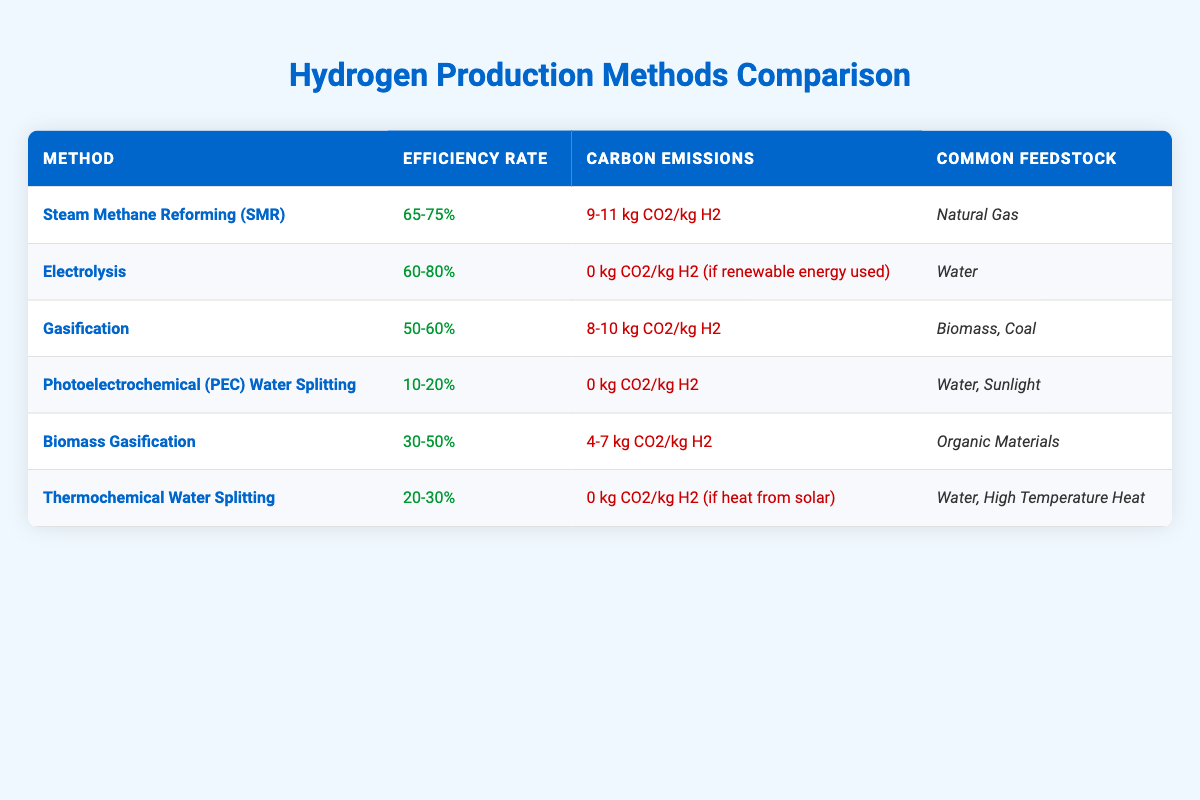What is the efficiency rate of Steam Methane Reforming (SMR)? The efficiency rate for Steam Methane Reforming (SMR) is found in the second column of the table under its respective row, which states "65-75%."
Answer: 65-75% Which hydrogen production method has the lowest efficiency rate? Looking at the efficiency rates listed, Photoelectrochemical (PEC) Water Splitting has the lowest efficiency rate of "10-20%," compared to others in the table.
Answer: Photoelectrochemical (PEC) Water Splitting What is the average carbon emissions of all the methods listed? To calculate the average carbon emissions, we take the average values of the emissions: SMR (10 kg), Electrolysis (0 kg), Gasification (9 kg), PEC (0 kg), Biomass Gasification (5.5 kg), and Thermochemical Water Splitting (0 kg). The sum is 24.5 kg and dividing by 6 gives us 4.08 kg CO2/kg H2.
Answer: 4.08 kg CO2/kg H2 Is Biomass Gasification associated with higher carbon emissions than Electrolysis? Comparing the carbon emissions, Biomass Gasification has emissions between "4-7 kg CO2/kg H2," while Electrolysis has "0 kg CO2/kg H2 (if renewable energy used)." Therefore, Biomass Gasification does indeed have higher emissions.
Answer: Yes Which methods have zero carbon emissions, and how many are there? The methods with zero carbon emissions are Electrolysis and Photoelectrochemical Water Splitting (PEC), both stated as "0 kg CO2/kg H2" in the table. Therefore, the total count of such methods is two.
Answer: 2 methods 